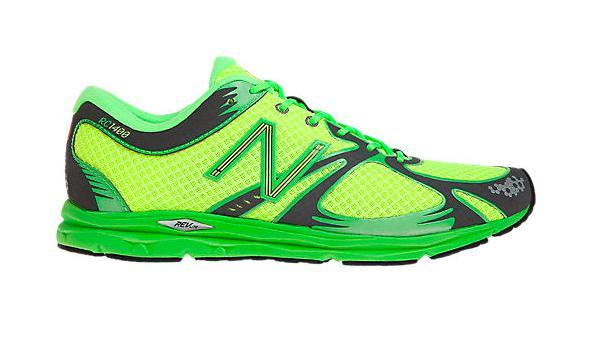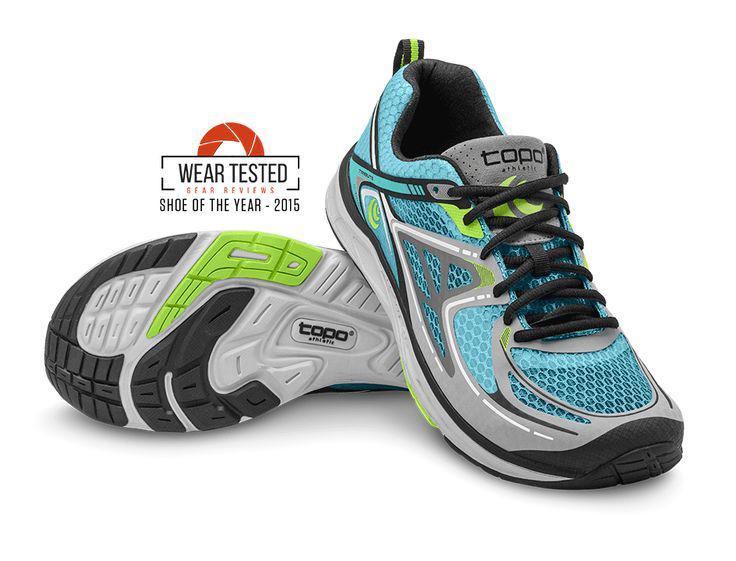The first image is the image on the left, the second image is the image on the right. For the images displayed, is the sentence "The image contains two brightly colored shoes stacked on top of eachother." factually correct? Answer yes or no. Yes. The first image is the image on the left, the second image is the image on the right. Assess this claim about the two images: "In at least one image there is one shoe that is sitting on top of another shoe.". Correct or not? Answer yes or no. Yes. 